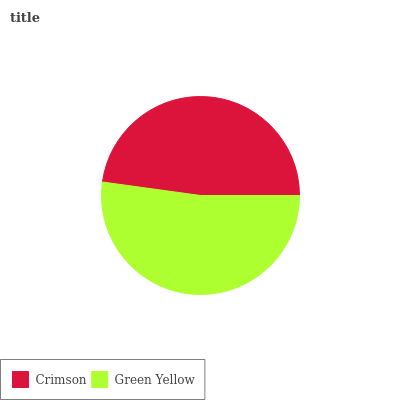Is Crimson the minimum?
Answer yes or no. Yes. Is Green Yellow the maximum?
Answer yes or no. Yes. Is Green Yellow the minimum?
Answer yes or no. No. Is Green Yellow greater than Crimson?
Answer yes or no. Yes. Is Crimson less than Green Yellow?
Answer yes or no. Yes. Is Crimson greater than Green Yellow?
Answer yes or no. No. Is Green Yellow less than Crimson?
Answer yes or no. No. Is Green Yellow the high median?
Answer yes or no. Yes. Is Crimson the low median?
Answer yes or no. Yes. Is Crimson the high median?
Answer yes or no. No. Is Green Yellow the low median?
Answer yes or no. No. 